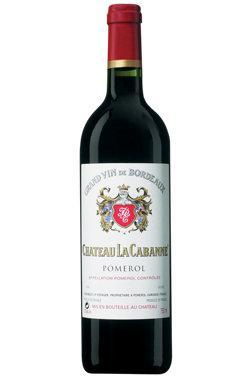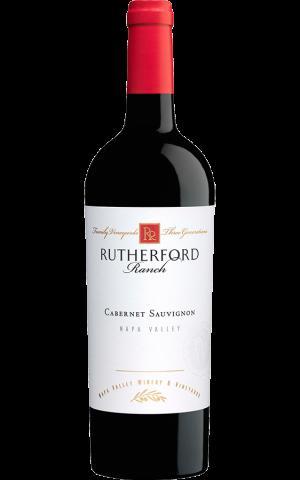The first image is the image on the left, the second image is the image on the right. Examine the images to the left and right. Is the description "The bottle in the image on the left has a screw-off cap." accurate? Answer yes or no. No. 